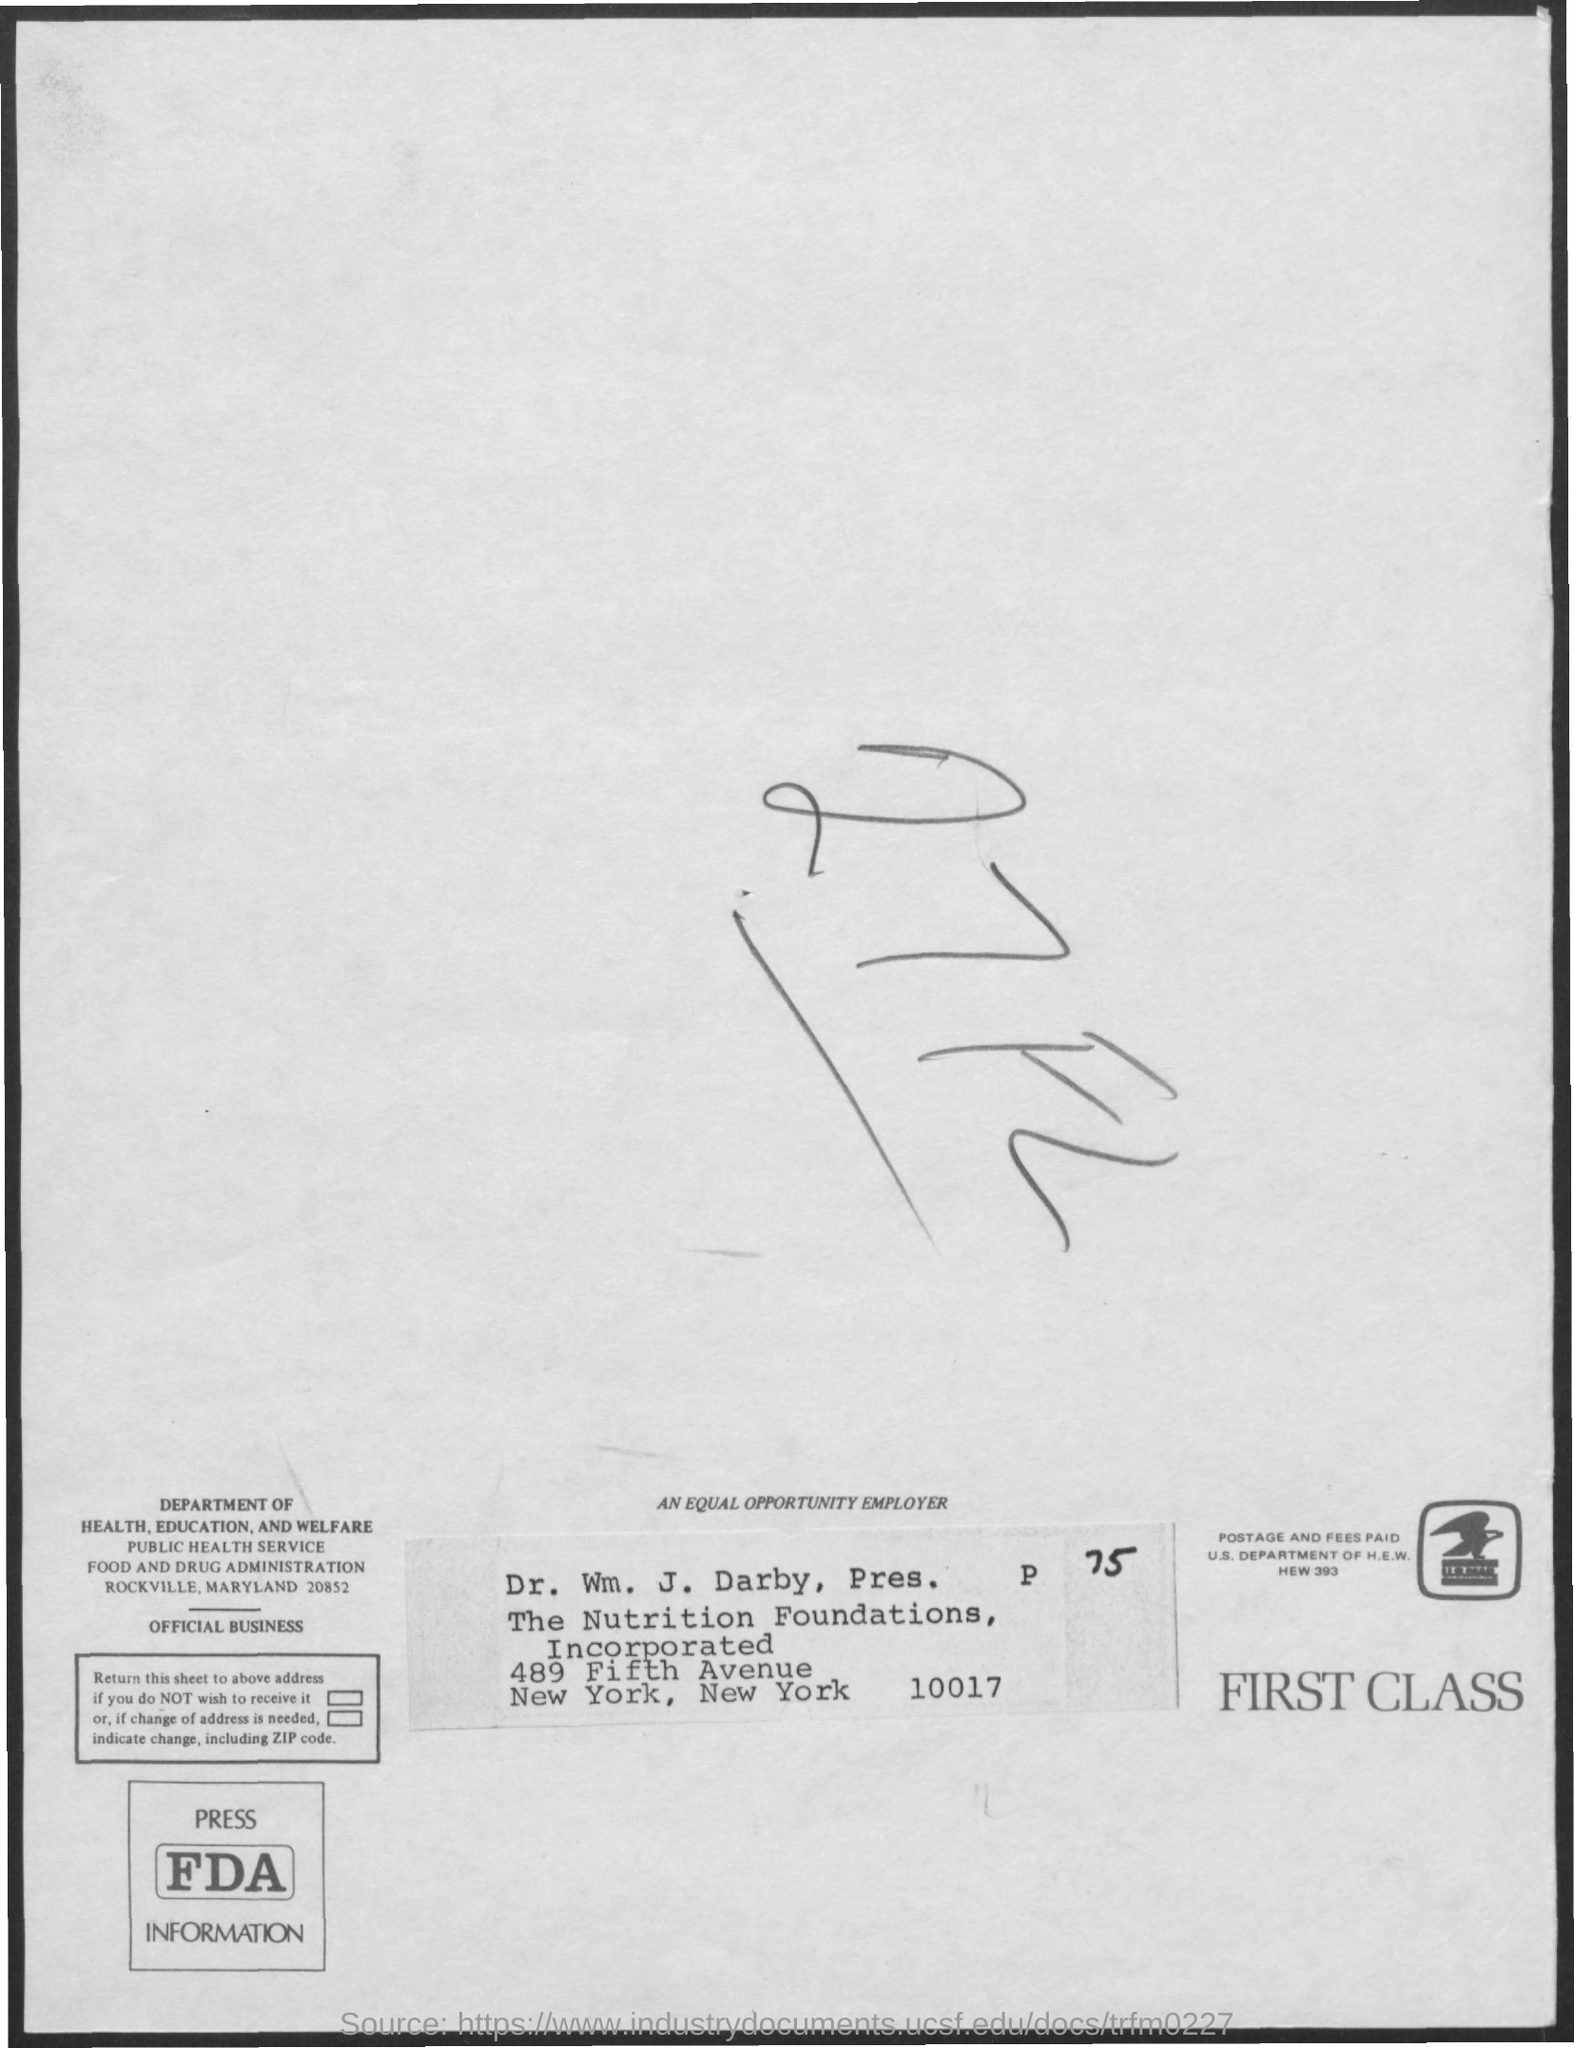Draw attention to some important aspects in this diagram. The document is written in handwriting that reads as 27FL.. 